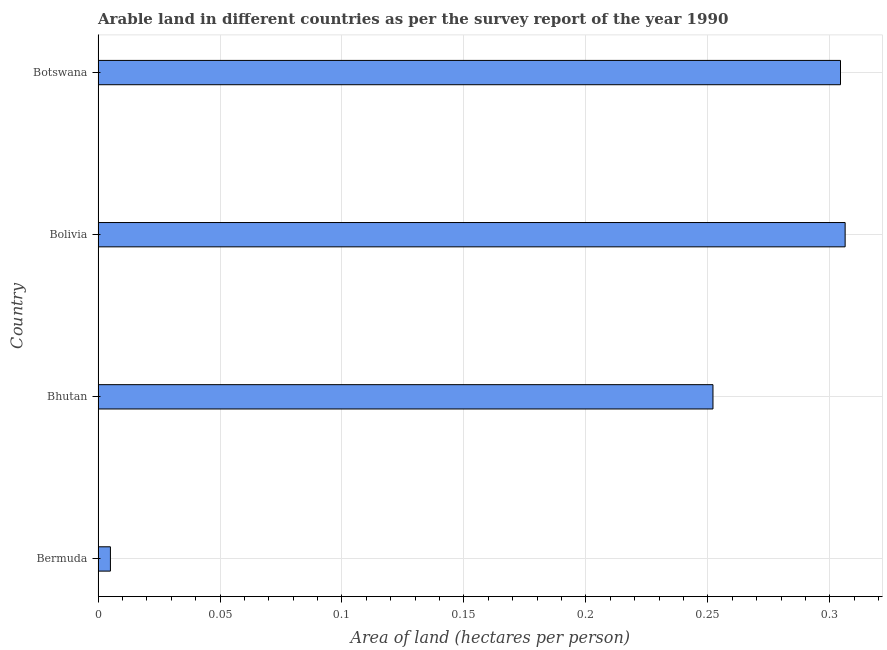Does the graph contain any zero values?
Give a very brief answer. No. What is the title of the graph?
Provide a succinct answer. Arable land in different countries as per the survey report of the year 1990. What is the label or title of the X-axis?
Offer a very short reply. Area of land (hectares per person). What is the label or title of the Y-axis?
Keep it short and to the point. Country. What is the area of arable land in Botswana?
Provide a short and direct response. 0.3. Across all countries, what is the maximum area of arable land?
Your response must be concise. 0.31. Across all countries, what is the minimum area of arable land?
Keep it short and to the point. 0.01. In which country was the area of arable land maximum?
Offer a very short reply. Bolivia. In which country was the area of arable land minimum?
Provide a short and direct response. Bermuda. What is the sum of the area of arable land?
Your answer should be compact. 0.87. What is the difference between the area of arable land in Bhutan and Bolivia?
Your answer should be very brief. -0.05. What is the average area of arable land per country?
Keep it short and to the point. 0.22. What is the median area of arable land?
Offer a very short reply. 0.28. What is the ratio of the area of arable land in Bhutan to that in Bolivia?
Provide a short and direct response. 0.82. Is the difference between the area of arable land in Bhutan and Botswana greater than the difference between any two countries?
Your answer should be compact. No. What is the difference between the highest and the second highest area of arable land?
Your answer should be very brief. 0. In how many countries, is the area of arable land greater than the average area of arable land taken over all countries?
Your answer should be compact. 3. How many bars are there?
Offer a very short reply. 4. Are all the bars in the graph horizontal?
Your answer should be very brief. Yes. What is the Area of land (hectares per person) in Bermuda?
Your response must be concise. 0.01. What is the Area of land (hectares per person) of Bhutan?
Give a very brief answer. 0.25. What is the Area of land (hectares per person) in Bolivia?
Keep it short and to the point. 0.31. What is the Area of land (hectares per person) of Botswana?
Make the answer very short. 0.3. What is the difference between the Area of land (hectares per person) in Bermuda and Bhutan?
Provide a succinct answer. -0.25. What is the difference between the Area of land (hectares per person) in Bermuda and Bolivia?
Ensure brevity in your answer.  -0.3. What is the difference between the Area of land (hectares per person) in Bermuda and Botswana?
Make the answer very short. -0.3. What is the difference between the Area of land (hectares per person) in Bhutan and Bolivia?
Keep it short and to the point. -0.05. What is the difference between the Area of land (hectares per person) in Bhutan and Botswana?
Provide a short and direct response. -0.05. What is the difference between the Area of land (hectares per person) in Bolivia and Botswana?
Ensure brevity in your answer.  0. What is the ratio of the Area of land (hectares per person) in Bermuda to that in Bhutan?
Provide a short and direct response. 0.02. What is the ratio of the Area of land (hectares per person) in Bermuda to that in Bolivia?
Your answer should be compact. 0.02. What is the ratio of the Area of land (hectares per person) in Bermuda to that in Botswana?
Your response must be concise. 0.02. What is the ratio of the Area of land (hectares per person) in Bhutan to that in Bolivia?
Provide a short and direct response. 0.82. What is the ratio of the Area of land (hectares per person) in Bhutan to that in Botswana?
Your response must be concise. 0.83. 